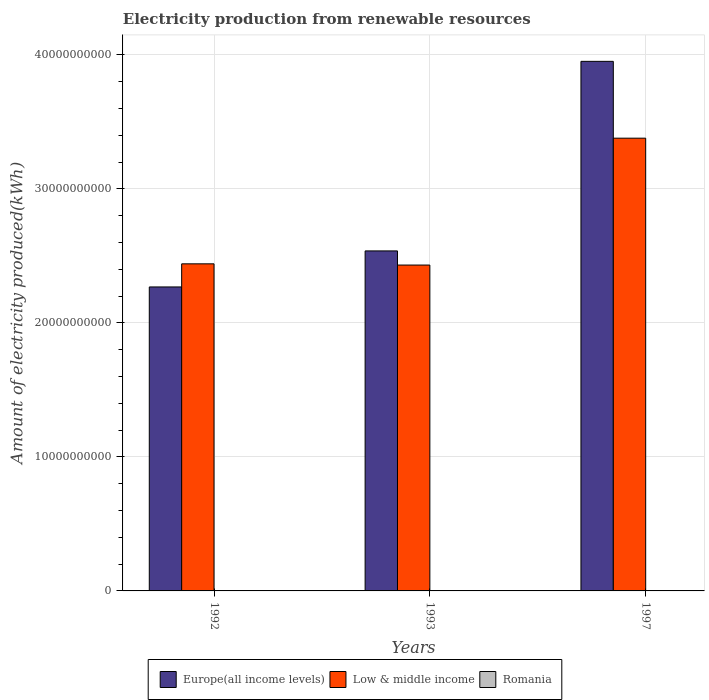Are the number of bars on each tick of the X-axis equal?
Provide a short and direct response. Yes. How many bars are there on the 3rd tick from the left?
Your response must be concise. 3. How many bars are there on the 1st tick from the right?
Provide a succinct answer. 3. What is the amount of electricity produced in Low & middle income in 1992?
Provide a short and direct response. 2.44e+1. Across all years, what is the maximum amount of electricity produced in Europe(all income levels)?
Make the answer very short. 3.95e+1. Across all years, what is the minimum amount of electricity produced in Romania?
Your answer should be compact. 1.00e+06. In which year was the amount of electricity produced in Europe(all income levels) maximum?
Your answer should be compact. 1997. In which year was the amount of electricity produced in Low & middle income minimum?
Your answer should be very brief. 1993. What is the total amount of electricity produced in Romania in the graph?
Give a very brief answer. 1.40e+07. What is the difference between the amount of electricity produced in Europe(all income levels) in 1993 and that in 1997?
Give a very brief answer. -1.41e+1. What is the difference between the amount of electricity produced in Romania in 1992 and the amount of electricity produced in Low & middle income in 1997?
Your answer should be compact. -3.38e+1. What is the average amount of electricity produced in Low & middle income per year?
Your response must be concise. 2.75e+1. In the year 1997, what is the difference between the amount of electricity produced in Low & middle income and amount of electricity produced in Europe(all income levels)?
Ensure brevity in your answer.  -5.73e+09. In how many years, is the amount of electricity produced in Low & middle income greater than 26000000000 kWh?
Provide a short and direct response. 1. What is the ratio of the amount of electricity produced in Europe(all income levels) in 1992 to that in 1993?
Provide a short and direct response. 0.89. Is the difference between the amount of electricity produced in Low & middle income in 1992 and 1997 greater than the difference between the amount of electricity produced in Europe(all income levels) in 1992 and 1997?
Make the answer very short. Yes. What is the difference between the highest and the second highest amount of electricity produced in Europe(all income levels)?
Your answer should be very brief. 1.41e+1. What is the difference between the highest and the lowest amount of electricity produced in Low & middle income?
Keep it short and to the point. 9.46e+09. In how many years, is the amount of electricity produced in Europe(all income levels) greater than the average amount of electricity produced in Europe(all income levels) taken over all years?
Make the answer very short. 1. What does the 1st bar from the left in 1993 represents?
Your response must be concise. Europe(all income levels). What does the 1st bar from the right in 1992 represents?
Provide a short and direct response. Romania. How many bars are there?
Offer a very short reply. 9. How many years are there in the graph?
Provide a succinct answer. 3. Does the graph contain any zero values?
Your answer should be very brief. No. How many legend labels are there?
Ensure brevity in your answer.  3. What is the title of the graph?
Keep it short and to the point. Electricity production from renewable resources. Does "Eritrea" appear as one of the legend labels in the graph?
Keep it short and to the point. No. What is the label or title of the X-axis?
Your response must be concise. Years. What is the label or title of the Y-axis?
Provide a short and direct response. Amount of electricity produced(kWh). What is the Amount of electricity produced(kWh) in Europe(all income levels) in 1992?
Your answer should be very brief. 2.27e+1. What is the Amount of electricity produced(kWh) of Low & middle income in 1992?
Ensure brevity in your answer.  2.44e+1. What is the Amount of electricity produced(kWh) in Romania in 1992?
Provide a succinct answer. 2.00e+06. What is the Amount of electricity produced(kWh) in Europe(all income levels) in 1993?
Ensure brevity in your answer.  2.54e+1. What is the Amount of electricity produced(kWh) in Low & middle income in 1993?
Make the answer very short. 2.43e+1. What is the Amount of electricity produced(kWh) of Romania in 1993?
Keep it short and to the point. 1.00e+06. What is the Amount of electricity produced(kWh) in Europe(all income levels) in 1997?
Provide a short and direct response. 3.95e+1. What is the Amount of electricity produced(kWh) of Low & middle income in 1997?
Keep it short and to the point. 3.38e+1. What is the Amount of electricity produced(kWh) of Romania in 1997?
Ensure brevity in your answer.  1.10e+07. Across all years, what is the maximum Amount of electricity produced(kWh) of Europe(all income levels)?
Give a very brief answer. 3.95e+1. Across all years, what is the maximum Amount of electricity produced(kWh) of Low & middle income?
Ensure brevity in your answer.  3.38e+1. Across all years, what is the maximum Amount of electricity produced(kWh) in Romania?
Provide a short and direct response. 1.10e+07. Across all years, what is the minimum Amount of electricity produced(kWh) of Europe(all income levels)?
Provide a succinct answer. 2.27e+1. Across all years, what is the minimum Amount of electricity produced(kWh) of Low & middle income?
Provide a short and direct response. 2.43e+1. Across all years, what is the minimum Amount of electricity produced(kWh) in Romania?
Provide a succinct answer. 1.00e+06. What is the total Amount of electricity produced(kWh) of Europe(all income levels) in the graph?
Your response must be concise. 8.76e+1. What is the total Amount of electricity produced(kWh) in Low & middle income in the graph?
Your response must be concise. 8.25e+1. What is the total Amount of electricity produced(kWh) in Romania in the graph?
Offer a very short reply. 1.40e+07. What is the difference between the Amount of electricity produced(kWh) in Europe(all income levels) in 1992 and that in 1993?
Your answer should be very brief. -2.69e+09. What is the difference between the Amount of electricity produced(kWh) of Low & middle income in 1992 and that in 1993?
Give a very brief answer. 9.10e+07. What is the difference between the Amount of electricity produced(kWh) in Europe(all income levels) in 1992 and that in 1997?
Provide a succinct answer. -1.68e+1. What is the difference between the Amount of electricity produced(kWh) in Low & middle income in 1992 and that in 1997?
Provide a short and direct response. -9.37e+09. What is the difference between the Amount of electricity produced(kWh) of Romania in 1992 and that in 1997?
Ensure brevity in your answer.  -9.00e+06. What is the difference between the Amount of electricity produced(kWh) in Europe(all income levels) in 1993 and that in 1997?
Give a very brief answer. -1.41e+1. What is the difference between the Amount of electricity produced(kWh) in Low & middle income in 1993 and that in 1997?
Make the answer very short. -9.46e+09. What is the difference between the Amount of electricity produced(kWh) in Romania in 1993 and that in 1997?
Provide a short and direct response. -1.00e+07. What is the difference between the Amount of electricity produced(kWh) in Europe(all income levels) in 1992 and the Amount of electricity produced(kWh) in Low & middle income in 1993?
Your answer should be compact. -1.63e+09. What is the difference between the Amount of electricity produced(kWh) of Europe(all income levels) in 1992 and the Amount of electricity produced(kWh) of Romania in 1993?
Give a very brief answer. 2.27e+1. What is the difference between the Amount of electricity produced(kWh) in Low & middle income in 1992 and the Amount of electricity produced(kWh) in Romania in 1993?
Your response must be concise. 2.44e+1. What is the difference between the Amount of electricity produced(kWh) in Europe(all income levels) in 1992 and the Amount of electricity produced(kWh) in Low & middle income in 1997?
Your response must be concise. -1.11e+1. What is the difference between the Amount of electricity produced(kWh) in Europe(all income levels) in 1992 and the Amount of electricity produced(kWh) in Romania in 1997?
Your answer should be very brief. 2.27e+1. What is the difference between the Amount of electricity produced(kWh) in Low & middle income in 1992 and the Amount of electricity produced(kWh) in Romania in 1997?
Give a very brief answer. 2.44e+1. What is the difference between the Amount of electricity produced(kWh) of Europe(all income levels) in 1993 and the Amount of electricity produced(kWh) of Low & middle income in 1997?
Give a very brief answer. -8.41e+09. What is the difference between the Amount of electricity produced(kWh) in Europe(all income levels) in 1993 and the Amount of electricity produced(kWh) in Romania in 1997?
Offer a terse response. 2.54e+1. What is the difference between the Amount of electricity produced(kWh) of Low & middle income in 1993 and the Amount of electricity produced(kWh) of Romania in 1997?
Ensure brevity in your answer.  2.43e+1. What is the average Amount of electricity produced(kWh) of Europe(all income levels) per year?
Keep it short and to the point. 2.92e+1. What is the average Amount of electricity produced(kWh) in Low & middle income per year?
Make the answer very short. 2.75e+1. What is the average Amount of electricity produced(kWh) in Romania per year?
Your answer should be compact. 4.67e+06. In the year 1992, what is the difference between the Amount of electricity produced(kWh) of Europe(all income levels) and Amount of electricity produced(kWh) of Low & middle income?
Offer a very short reply. -1.72e+09. In the year 1992, what is the difference between the Amount of electricity produced(kWh) in Europe(all income levels) and Amount of electricity produced(kWh) in Romania?
Your response must be concise. 2.27e+1. In the year 1992, what is the difference between the Amount of electricity produced(kWh) in Low & middle income and Amount of electricity produced(kWh) in Romania?
Offer a very short reply. 2.44e+1. In the year 1993, what is the difference between the Amount of electricity produced(kWh) of Europe(all income levels) and Amount of electricity produced(kWh) of Low & middle income?
Keep it short and to the point. 1.06e+09. In the year 1993, what is the difference between the Amount of electricity produced(kWh) of Europe(all income levels) and Amount of electricity produced(kWh) of Romania?
Make the answer very short. 2.54e+1. In the year 1993, what is the difference between the Amount of electricity produced(kWh) of Low & middle income and Amount of electricity produced(kWh) of Romania?
Make the answer very short. 2.43e+1. In the year 1997, what is the difference between the Amount of electricity produced(kWh) of Europe(all income levels) and Amount of electricity produced(kWh) of Low & middle income?
Your answer should be compact. 5.73e+09. In the year 1997, what is the difference between the Amount of electricity produced(kWh) in Europe(all income levels) and Amount of electricity produced(kWh) in Romania?
Keep it short and to the point. 3.95e+1. In the year 1997, what is the difference between the Amount of electricity produced(kWh) of Low & middle income and Amount of electricity produced(kWh) of Romania?
Offer a very short reply. 3.38e+1. What is the ratio of the Amount of electricity produced(kWh) in Europe(all income levels) in 1992 to that in 1993?
Offer a terse response. 0.89. What is the ratio of the Amount of electricity produced(kWh) of Romania in 1992 to that in 1993?
Keep it short and to the point. 2. What is the ratio of the Amount of electricity produced(kWh) in Europe(all income levels) in 1992 to that in 1997?
Give a very brief answer. 0.57. What is the ratio of the Amount of electricity produced(kWh) of Low & middle income in 1992 to that in 1997?
Offer a very short reply. 0.72. What is the ratio of the Amount of electricity produced(kWh) in Romania in 1992 to that in 1997?
Ensure brevity in your answer.  0.18. What is the ratio of the Amount of electricity produced(kWh) of Europe(all income levels) in 1993 to that in 1997?
Your answer should be compact. 0.64. What is the ratio of the Amount of electricity produced(kWh) in Low & middle income in 1993 to that in 1997?
Make the answer very short. 0.72. What is the ratio of the Amount of electricity produced(kWh) of Romania in 1993 to that in 1997?
Your answer should be very brief. 0.09. What is the difference between the highest and the second highest Amount of electricity produced(kWh) in Europe(all income levels)?
Make the answer very short. 1.41e+1. What is the difference between the highest and the second highest Amount of electricity produced(kWh) in Low & middle income?
Provide a short and direct response. 9.37e+09. What is the difference between the highest and the second highest Amount of electricity produced(kWh) of Romania?
Give a very brief answer. 9.00e+06. What is the difference between the highest and the lowest Amount of electricity produced(kWh) of Europe(all income levels)?
Offer a very short reply. 1.68e+1. What is the difference between the highest and the lowest Amount of electricity produced(kWh) in Low & middle income?
Provide a short and direct response. 9.46e+09. 